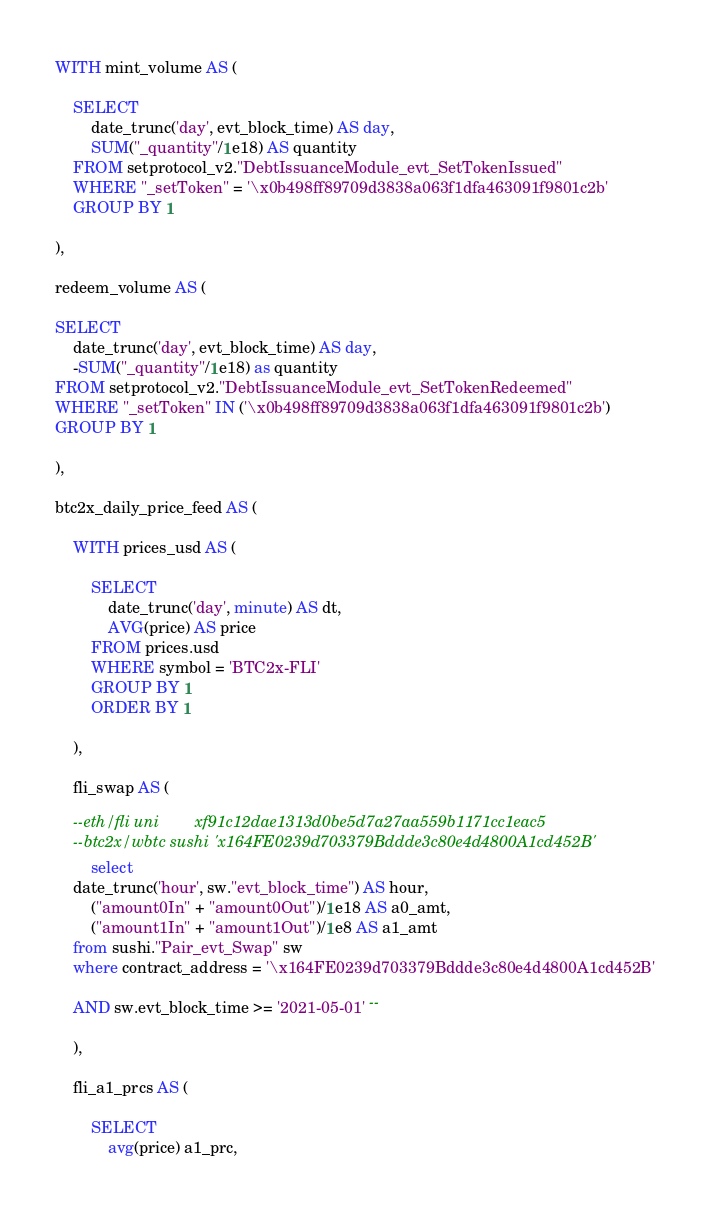<code> <loc_0><loc_0><loc_500><loc_500><_SQL_>WITH mint_volume AS (

    SELECT 
        date_trunc('day', evt_block_time) AS day, 
        SUM("_quantity"/1e18) AS quantity
    FROM setprotocol_v2."DebtIssuanceModule_evt_SetTokenIssued"
    WHERE "_setToken" = '\x0b498ff89709d3838a063f1dfa463091f9801c2b'
    GROUP BY 1

),

redeem_volume AS (

SELECT
    date_trunc('day', evt_block_time) AS day,
    -SUM("_quantity"/1e18) as quantity
FROM setprotocol_v2."DebtIssuanceModule_evt_SetTokenRedeemed"
WHERE "_setToken" IN ('\x0b498ff89709d3838a063f1dfa463091f9801c2b')
GROUP BY 1

),

btc2x_daily_price_feed AS (

    WITH prices_usd AS (
    
        SELECT
            date_trunc('day', minute) AS dt,
            AVG(price) AS price
        FROM prices.usd
        WHERE symbol = 'BTC2x-FLI'
        GROUP BY 1
        ORDER BY 1
        
    ),
    
    fli_swap AS (
    
    --eth/fli uni        xf91c12dae1313d0be5d7a27aa559b1171cc1eac5
    --btc2x/wbtc sushi 'x164FE0239d703379Bddde3c80e4d4800A1cd452B'    
        select 
    date_trunc('hour', sw."evt_block_time") AS hour,
        ("amount0In" + "amount0Out")/1e18 AS a0_amt, 
        ("amount1In" + "amount1Out")/1e8 AS a1_amt
    from sushi."Pair_evt_Swap" sw
    where contract_address = '\x164FE0239d703379Bddde3c80e4d4800A1cd452B'

    AND sw.evt_block_time >= '2021-05-01' -- 
    
    ),
    
    fli_a1_prcs AS (
    
        SELECT 
            avg(price) a1_prc, </code> 